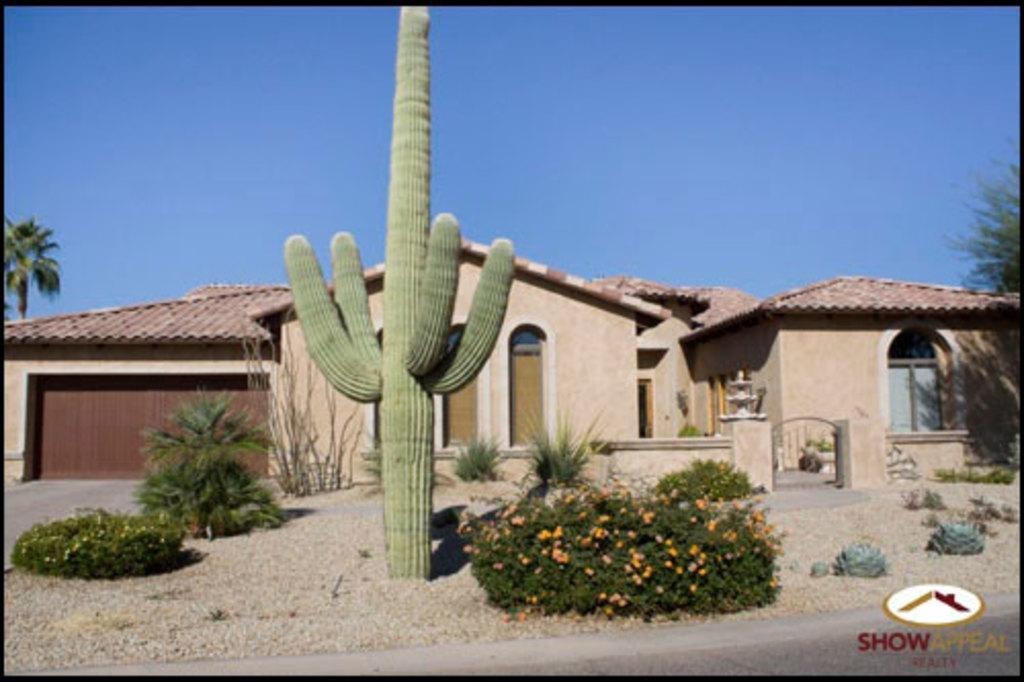What type of living organisms can be seen in the image? Plants can be seen in the image. What structure is located in the middle of the image? There is a shelter house in the middle of the image. What is visible at the top of the image? The sky is visible at the top of the image. What type of marble is used to construct the shelter house in the image? There is no mention of marble being used in the construction of the shelter house in the image. Can you see a volleyball game being played in the image? There is no indication of a volleyball game or any sports activity in the image. 